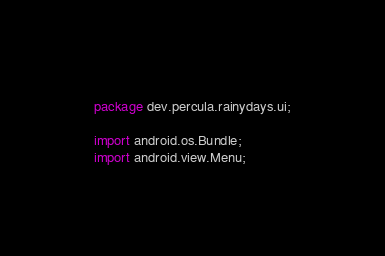Convert code to text. <code><loc_0><loc_0><loc_500><loc_500><_Java_>package dev.percula.rainydays.ui;

import android.os.Bundle;
import android.view.Menu;</code> 